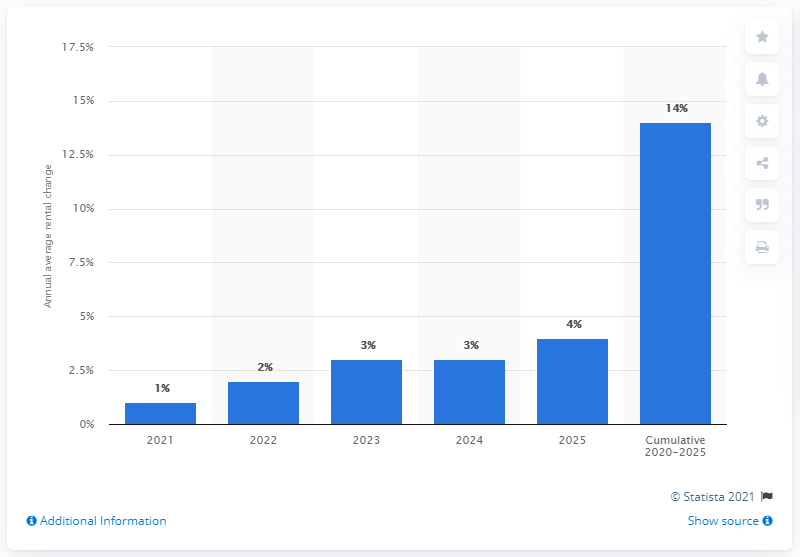Highlight a few significant elements in this photo. Over the entire projection period, rents are expected to grow by approximately 14%. 